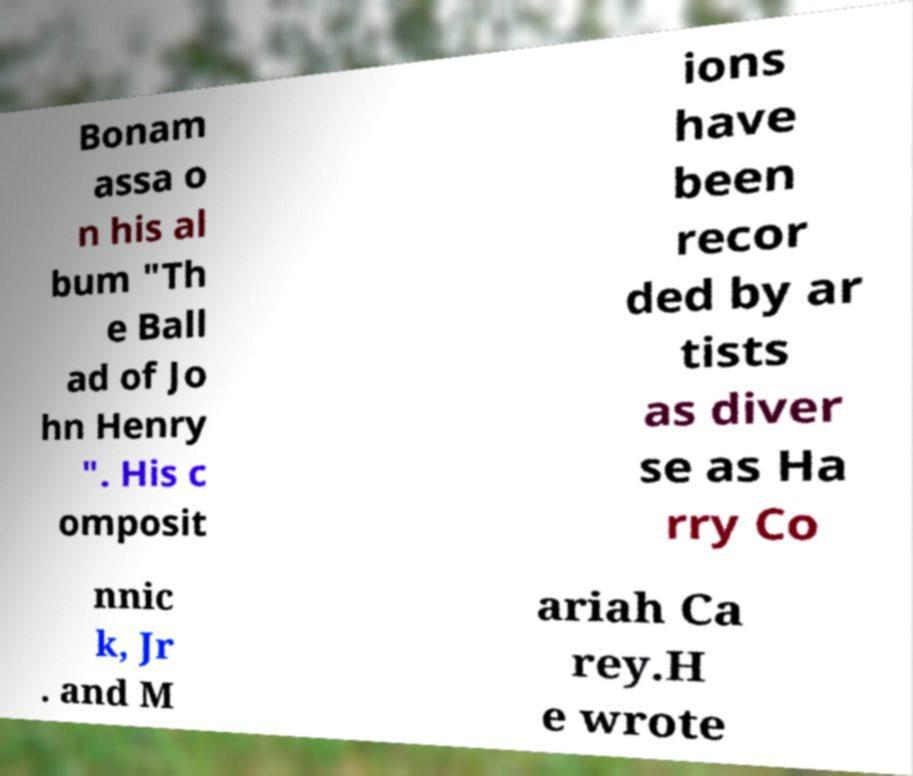Can you read and provide the text displayed in the image?This photo seems to have some interesting text. Can you extract and type it out for me? Bonam assa o n his al bum "Th e Ball ad of Jo hn Henry ". His c omposit ions have been recor ded by ar tists as diver se as Ha rry Co nnic k, Jr . and M ariah Ca rey.H e wrote 